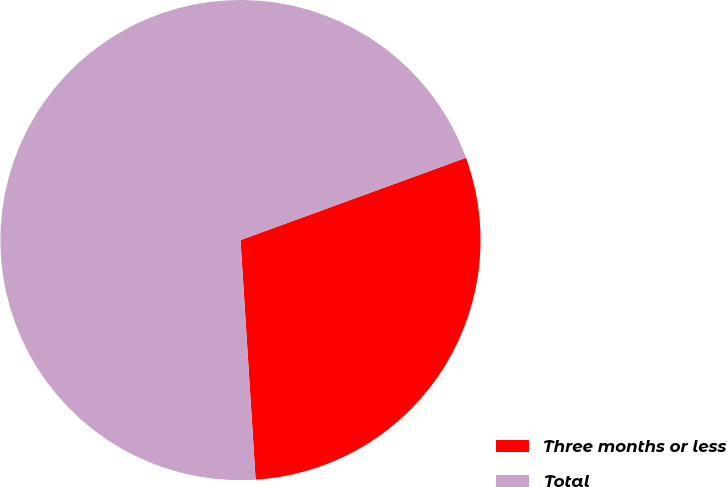Convert chart to OTSL. <chart><loc_0><loc_0><loc_500><loc_500><pie_chart><fcel>Three months or less<fcel>Total<nl><fcel>29.57%<fcel>70.43%<nl></chart> 